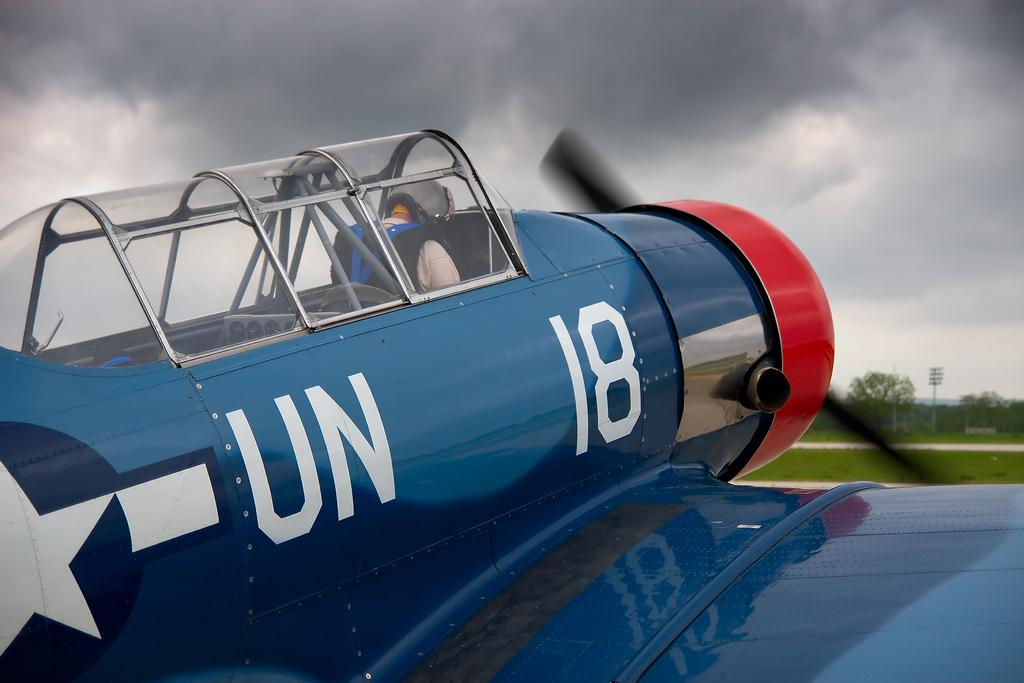<image>
Render a clear and concise summary of the photo. the blue plane hays UN 18 and has a red propeller mount 